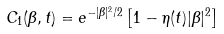<formula> <loc_0><loc_0><loc_500><loc_500>C _ { 1 } ( \beta , t ) = e ^ { - | \beta | ^ { 2 } / 2 } \left [ 1 - \eta ( t ) | \beta | ^ { 2 } \right ]</formula> 